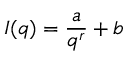Convert formula to latex. <formula><loc_0><loc_0><loc_500><loc_500>I ( q ) = \frac { a } { q ^ { r } } + b</formula> 